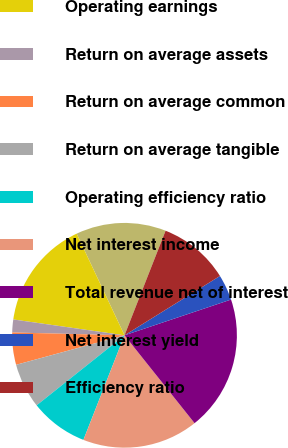Convert chart to OTSL. <chart><loc_0><loc_0><loc_500><loc_500><pie_chart><fcel>(Dollars in millions)<fcel>Operating earnings<fcel>Return on average assets<fcel>Return on average common<fcel>Return on average tangible<fcel>Operating efficiency ratio<fcel>Net interest income<fcel>Total revenue net of interest<fcel>Net interest yield<fcel>Efficiency ratio<nl><fcel>12.96%<fcel>15.74%<fcel>1.85%<fcel>4.63%<fcel>6.48%<fcel>8.33%<fcel>16.67%<fcel>19.44%<fcel>3.7%<fcel>10.19%<nl></chart> 